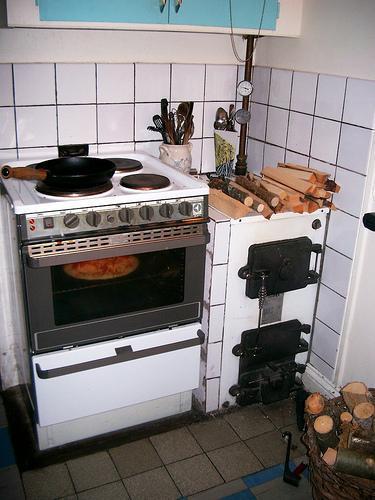Is the statement "The pizza is inside the oven." accurate regarding the image?
Answer yes or no. Yes. Is this affirmation: "The oven contains the pizza." correct?
Answer yes or no. Yes. Is the given caption "The pizza is in the oven." fitting for the image?
Answer yes or no. Yes. 